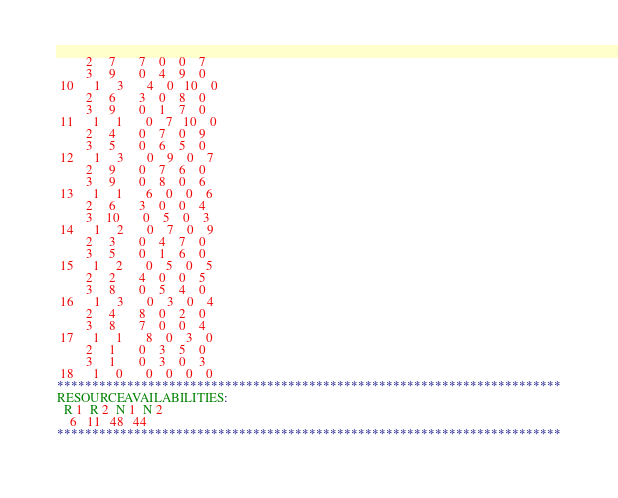<code> <loc_0><loc_0><loc_500><loc_500><_ObjectiveC_>         2     7       7    0    0    7
         3     9       0    4    9    0
 10      1     3       4    0   10    0
         2     6       3    0    8    0
         3     9       0    1    7    0
 11      1     1       0    7   10    0
         2     4       0    7    0    9
         3     5       0    6    5    0
 12      1     3       0    9    0    7
         2     9       0    7    6    0
         3     9       0    8    0    6
 13      1     1       6    0    0    6
         2     6       3    0    0    4
         3    10       0    5    0    3
 14      1     2       0    7    0    9
         2     3       0    4    7    0
         3     5       0    1    6    0
 15      1     2       0    5    0    5
         2     2       4    0    0    5
         3     8       0    5    4    0
 16      1     3       0    3    0    4
         2     4       8    0    2    0
         3     8       7    0    0    4
 17      1     1       8    0    3    0
         2     1       0    3    5    0
         3     1       0    3    0    3
 18      1     0       0    0    0    0
************************************************************************
RESOURCEAVAILABILITIES:
  R 1  R 2  N 1  N 2
    6   11   48   44
************************************************************************
</code> 